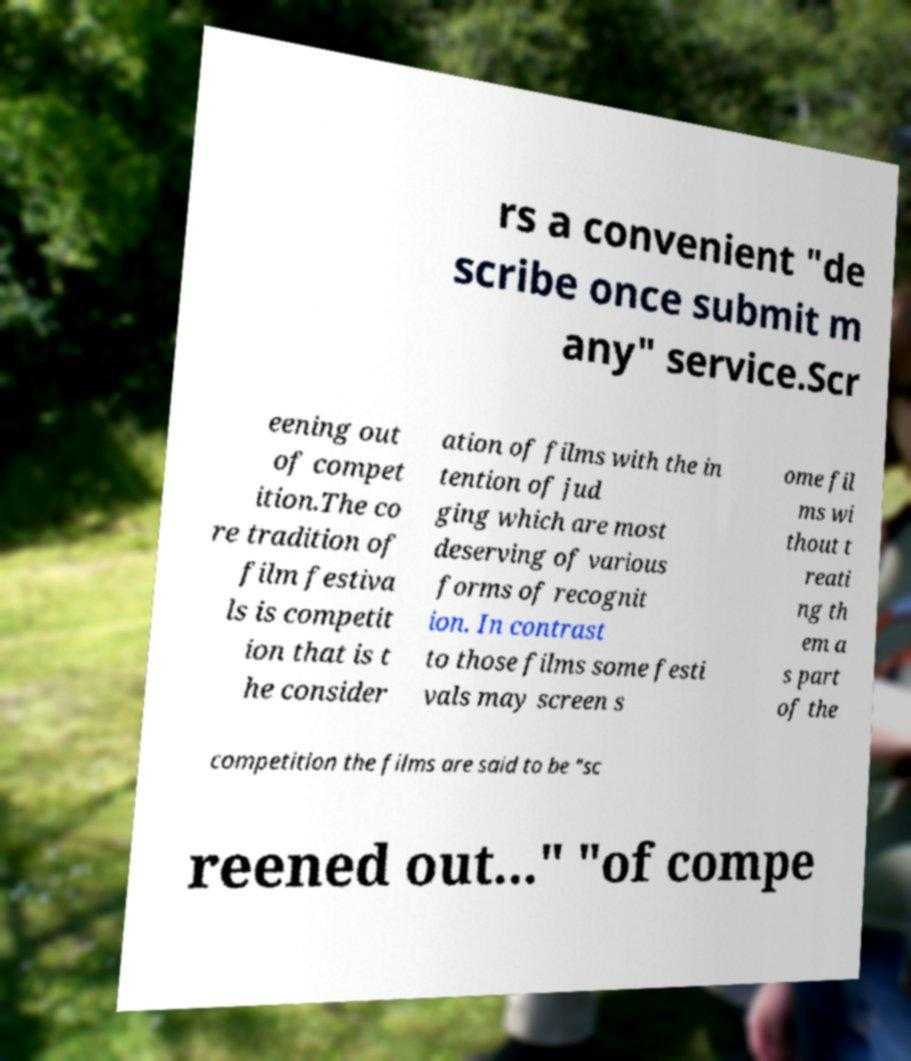I need the written content from this picture converted into text. Can you do that? rs a convenient "de scribe once submit m any" service.Scr eening out of compet ition.The co re tradition of film festiva ls is competit ion that is t he consider ation of films with the in tention of jud ging which are most deserving of various forms of recognit ion. In contrast to those films some festi vals may screen s ome fil ms wi thout t reati ng th em a s part of the competition the films are said to be "sc reened out..." "of compe 